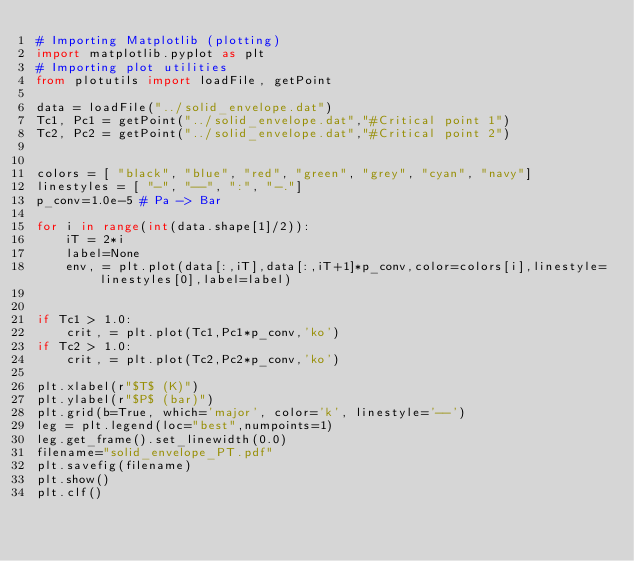Convert code to text. <code><loc_0><loc_0><loc_500><loc_500><_Python_># Importing Matplotlib (plotting)
import matplotlib.pyplot as plt
# Importing plot utilities
from plotutils import loadFile, getPoint

data = loadFile("../solid_envelope.dat")
Tc1, Pc1 = getPoint("../solid_envelope.dat","#Critical point 1")
Tc2, Pc2 = getPoint("../solid_envelope.dat","#Critical point 2")


colors = [ "black", "blue", "red", "green", "grey", "cyan", "navy"]
linestyles = [ "-", "--", ":", "-."]
p_conv=1.0e-5 # Pa -> Bar

for i in range(int(data.shape[1]/2)):
    iT = 2*i
    label=None
    env, = plt.plot(data[:,iT],data[:,iT+1]*p_conv,color=colors[i],linestyle=linestyles[0],label=label)


if Tc1 > 1.0:
    crit, = plt.plot(Tc1,Pc1*p_conv,'ko')
if Tc2 > 1.0:
    crit, = plt.plot(Tc2,Pc2*p_conv,'ko')

plt.xlabel(r"$T$ (K)")
plt.ylabel(r"$P$ (bar)")
plt.grid(b=True, which='major', color='k', linestyle='--')
leg = plt.legend(loc="best",numpoints=1)
leg.get_frame().set_linewidth(0.0)
filename="solid_envelope_PT.pdf"
plt.savefig(filename)
plt.show()
plt.clf()
</code> 